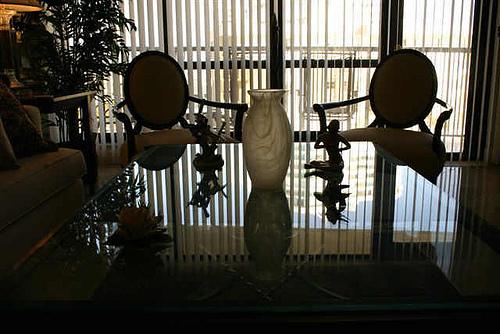Are there reflections on  the table?
Keep it brief. Yes. Is it daytime?
Keep it brief. Yes. How many chairs are there?
Concise answer only. 2. 